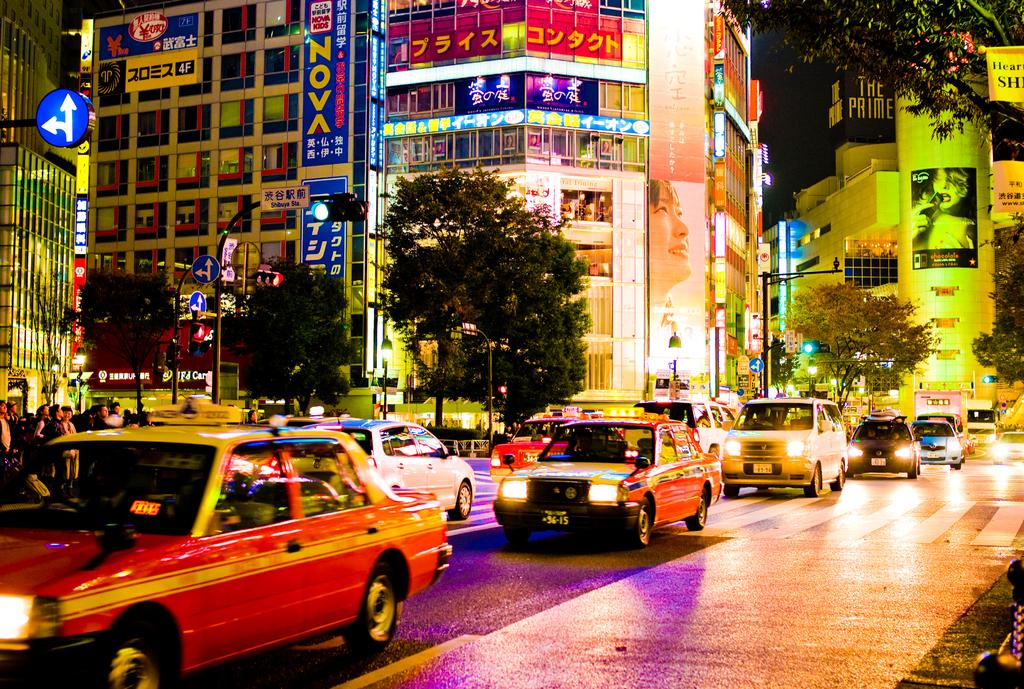<image>
Render a clear and concise summary of the photo. A busy street scene in Japan with an advert for Nova Kids on the facia of one building. 